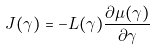<formula> <loc_0><loc_0><loc_500><loc_500>J ( \gamma ) = - L ( \gamma ) \frac { \partial \mu ( \gamma ) } { \partial \gamma }</formula> 